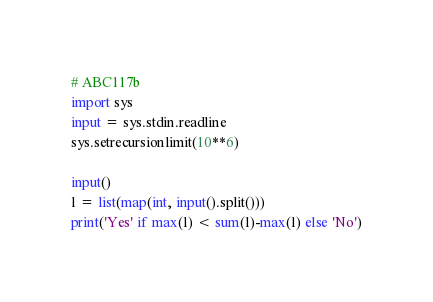Convert code to text. <code><loc_0><loc_0><loc_500><loc_500><_Python_># ABC117b
import sys
input = sys.stdin.readline
sys.setrecursionlimit(10**6)

input()
l = list(map(int, input().split()))
print('Yes' if max(l) < sum(l)-max(l) else 'No')
</code> 